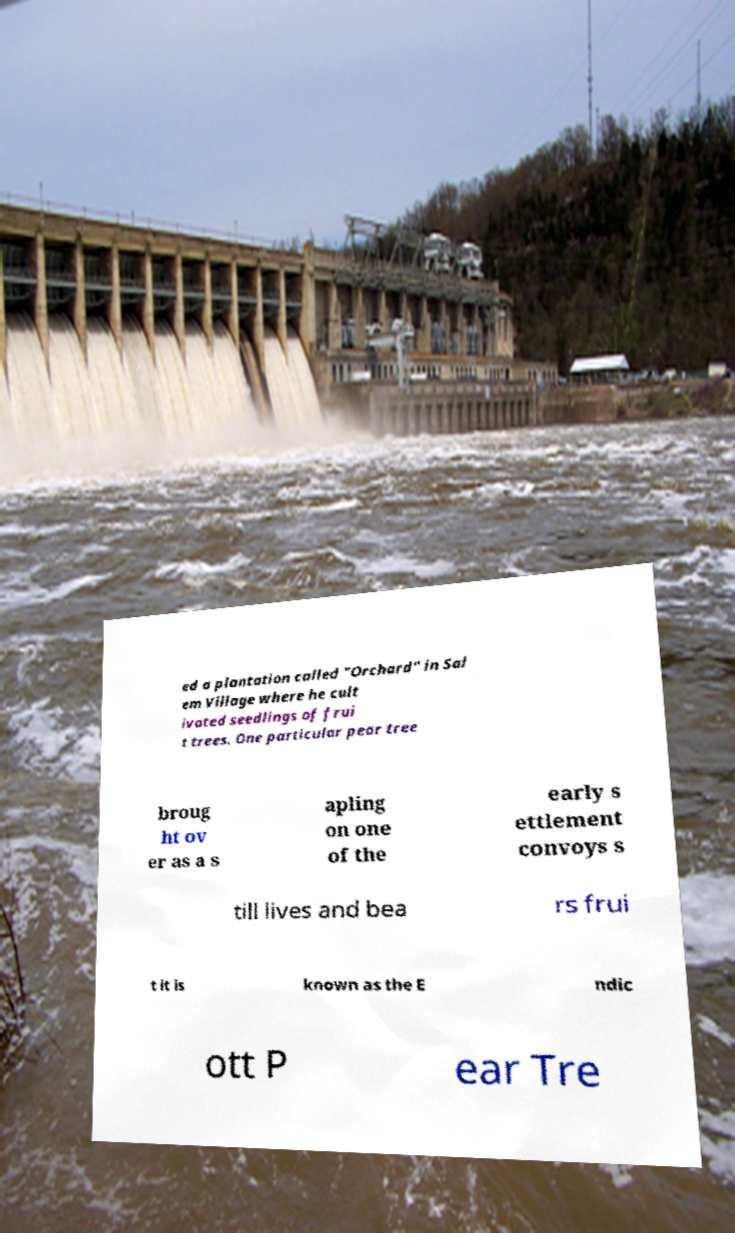What messages or text are displayed in this image? I need them in a readable, typed format. ed a plantation called "Orchard" in Sal em Village where he cult ivated seedlings of frui t trees. One particular pear tree broug ht ov er as a s apling on one of the early s ettlement convoys s till lives and bea rs frui t it is known as the E ndic ott P ear Tre 